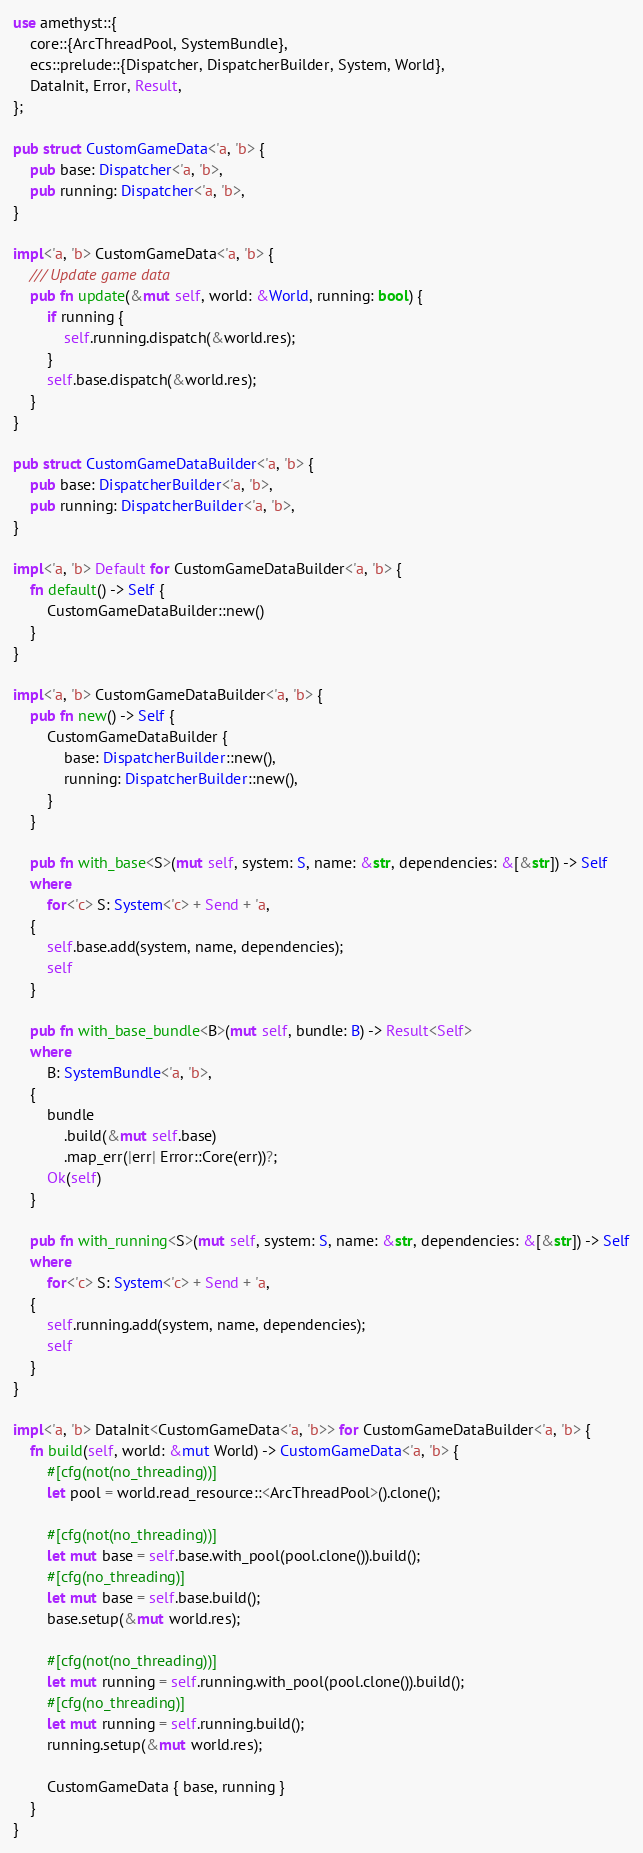Convert code to text. <code><loc_0><loc_0><loc_500><loc_500><_Rust_>use amethyst::{
    core::{ArcThreadPool, SystemBundle},
    ecs::prelude::{Dispatcher, DispatcherBuilder, System, World},
    DataInit, Error, Result,
};

pub struct CustomGameData<'a, 'b> {
    pub base: Dispatcher<'a, 'b>,
    pub running: Dispatcher<'a, 'b>,
}

impl<'a, 'b> CustomGameData<'a, 'b> {
    /// Update game data
    pub fn update(&mut self, world: &World, running: bool) {
        if running {
            self.running.dispatch(&world.res);
        }
        self.base.dispatch(&world.res);
    }
}

pub struct CustomGameDataBuilder<'a, 'b> {
    pub base: DispatcherBuilder<'a, 'b>,
    pub running: DispatcherBuilder<'a, 'b>,
}

impl<'a, 'b> Default for CustomGameDataBuilder<'a, 'b> {
    fn default() -> Self {
        CustomGameDataBuilder::new()
    }
}

impl<'a, 'b> CustomGameDataBuilder<'a, 'b> {
    pub fn new() -> Self {
        CustomGameDataBuilder {
            base: DispatcherBuilder::new(),
            running: DispatcherBuilder::new(),
        }
    }

    pub fn with_base<S>(mut self, system: S, name: &str, dependencies: &[&str]) -> Self
    where
        for<'c> S: System<'c> + Send + 'a,
    {
        self.base.add(system, name, dependencies);
        self
    }

    pub fn with_base_bundle<B>(mut self, bundle: B) -> Result<Self>
    where
        B: SystemBundle<'a, 'b>,
    {
        bundle
            .build(&mut self.base)
            .map_err(|err| Error::Core(err))?;
        Ok(self)
    }

    pub fn with_running<S>(mut self, system: S, name: &str, dependencies: &[&str]) -> Self
    where
        for<'c> S: System<'c> + Send + 'a,
    {
        self.running.add(system, name, dependencies);
        self
    }
}

impl<'a, 'b> DataInit<CustomGameData<'a, 'b>> for CustomGameDataBuilder<'a, 'b> {
    fn build(self, world: &mut World) -> CustomGameData<'a, 'b> {
        #[cfg(not(no_threading))]
        let pool = world.read_resource::<ArcThreadPool>().clone();

        #[cfg(not(no_threading))]
        let mut base = self.base.with_pool(pool.clone()).build();
        #[cfg(no_threading)]
        let mut base = self.base.build();
        base.setup(&mut world.res);

        #[cfg(not(no_threading))]
        let mut running = self.running.with_pool(pool.clone()).build();
        #[cfg(no_threading)]
        let mut running = self.running.build();
        running.setup(&mut world.res);

        CustomGameData { base, running }
    }
}
</code> 